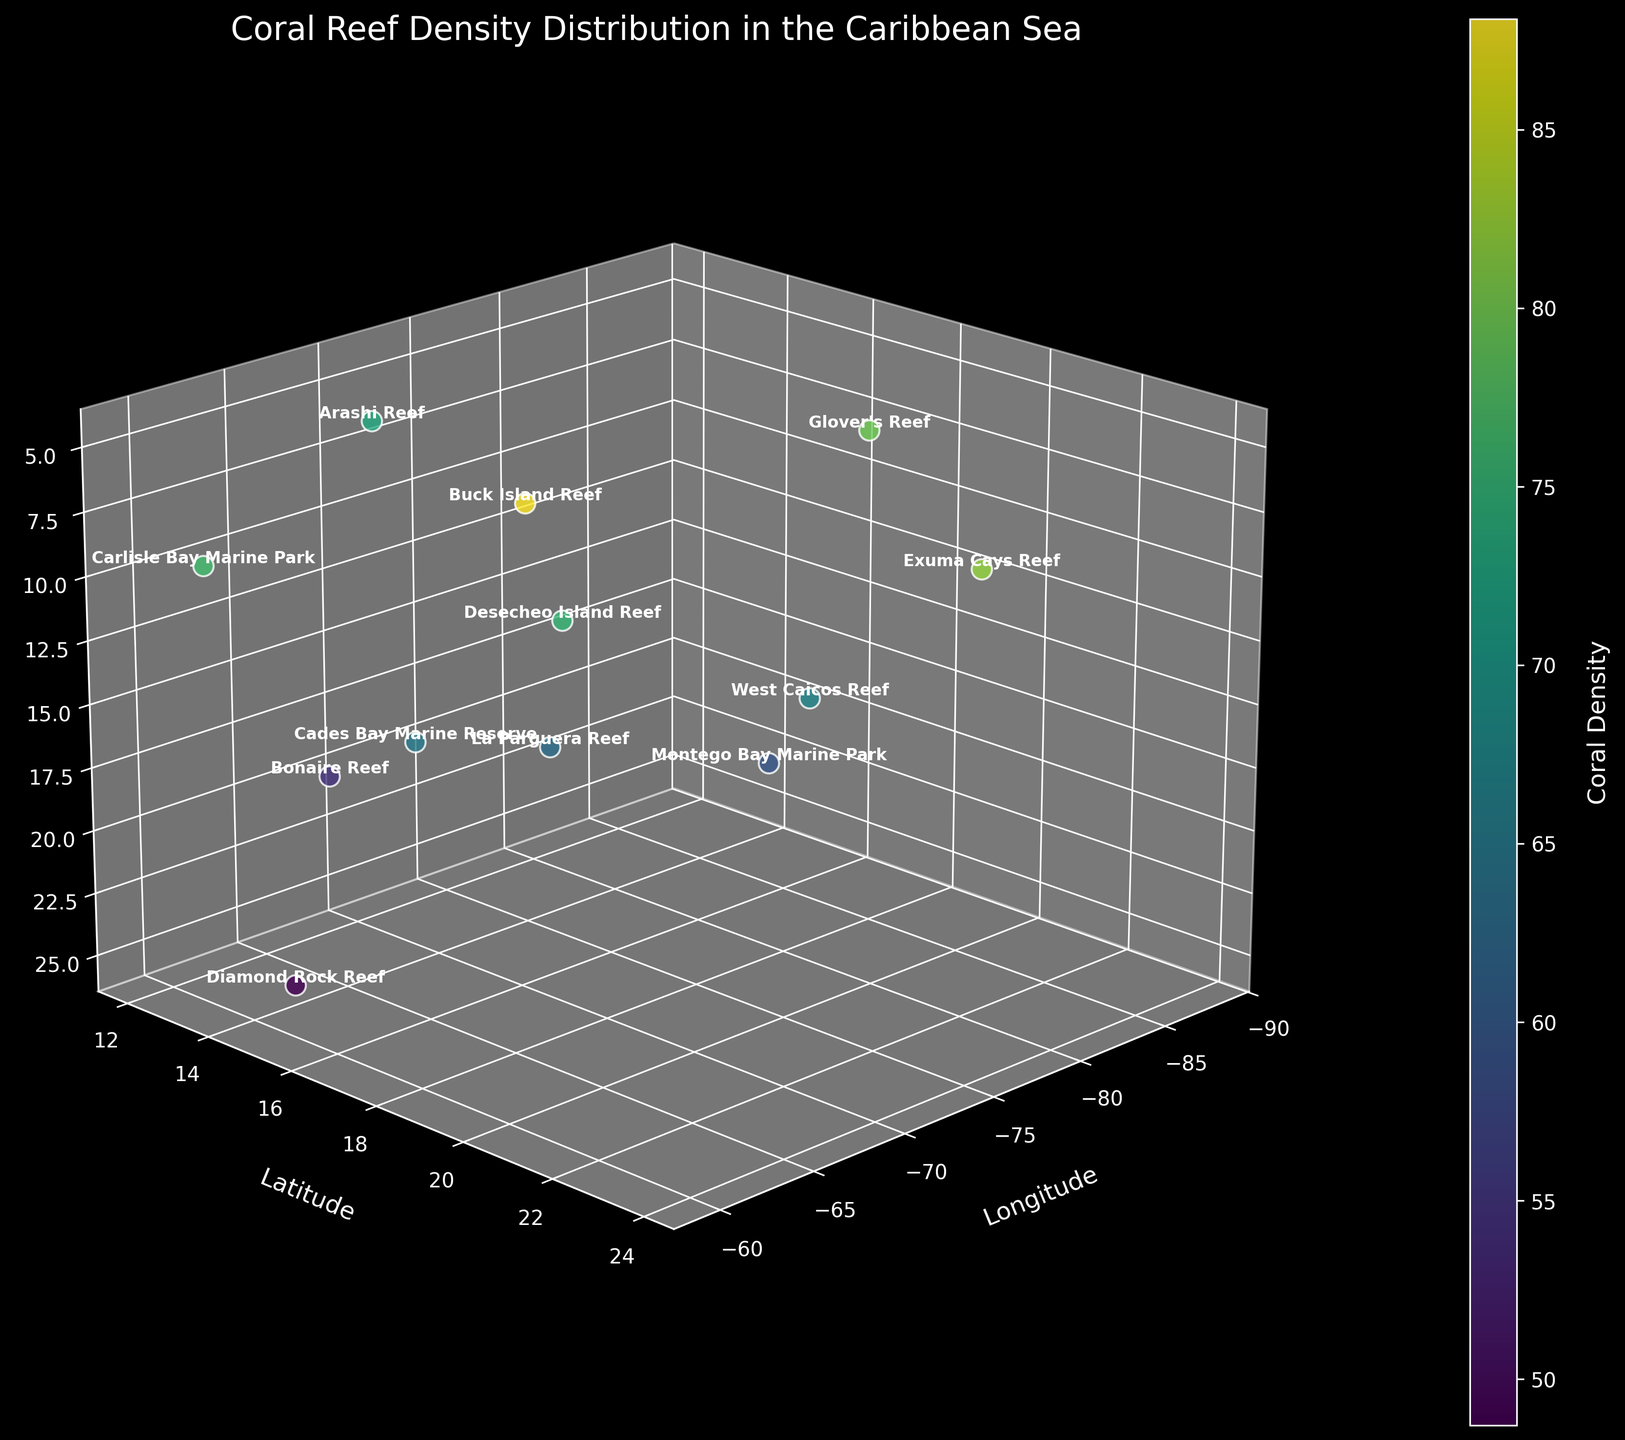How many coral reefs are depicted in the figure? Count all the different points corresponding to reef names on the figure. Each point represents a different coral reef, so counting these points gives the number of coral reefs.
Answer: 12 Which reef has the highest coral density? Look at the color gradient on the points and refer to the color bar that indicates coral density. Identify the point with the most intense color corresponding to the highest value.
Answer: Buck Island Reef How does the coral density at Montego Bay Marine Park compare to Carlisle Bay Marine Park? Refer to the color shades of both points and check their position in the color bar. Compare the coral density values directly. Carlisle Bay Marine Park has a higher density than Montego Bay Marine Park.
Answer: Lower What is the range of depths for the coral reefs in the figure? Identify the minimum and maximum values along the depth (Z) axis to find the range of depths for the coral reefs.
Answer: 5 to 25 meters Which coral reef is located at the shallowest depth? Find the point with the smallest depth value on the Z-axis (closest to the top of the plot). According to the figure, Buck Island Reef is at the shallowest depth.
Answer: Buck Island Reef What is the average coral density of the reefs? Sum the coral density values for all the reefs and divide by the number of reefs (12). The sum of coral densities is 791.7. The average density is 791.7/12.
Answer: 65.98 Which reef has the largest latitude? Look at the Y-axis (latitude) and find the point with the highest latitude value. According to the figure, Exuma Cays Reef has the largest latitude value.
Answer: Exuma Cays Reef Which two reefs have the closest coral density values? Compare the coral density values of all reefs and identify the two with the smallest difference. West Caicos Reef with 67.2 and Cades Bay Marine Reserve with 65.1 have the closest values.
Answer: West Caicos Reef and Cades Bay Marine Reserve How is coral density represented in the figure? Identify the visual element that changes with coral density (i.e., color). Coral density is represented through the color of the points, with the color gradient shown by the color bar linking to density values.
Answer: By color Do deeper reefs generally have lower coral densities? Look at the points representing deeper reefs (higher depth values on the Z-axis) and compare their colors to those of shallower reefs. Deeper reefs generally appear with colors indicating lower densities, supporting the hypothesis.
Answer: Yes 